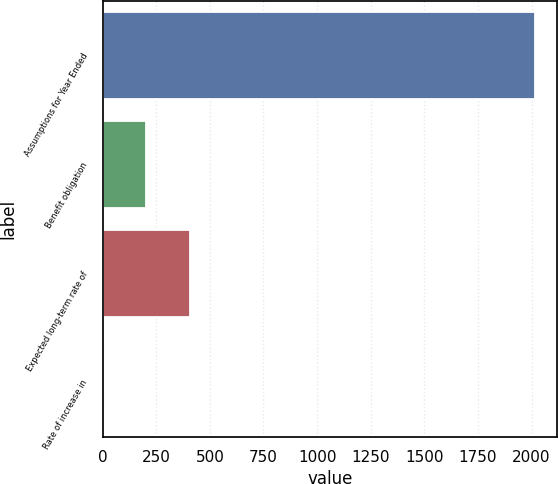<chart> <loc_0><loc_0><loc_500><loc_500><bar_chart><fcel>Assumptions for Year Ended<fcel>Benefit obligation<fcel>Expected long-term rate of<fcel>Rate of increase in<nl><fcel>2017<fcel>204.31<fcel>405.72<fcel>2.9<nl></chart> 